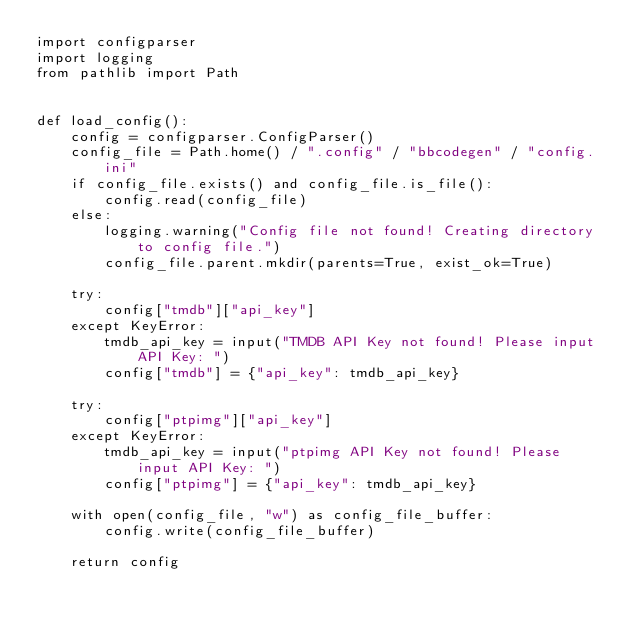Convert code to text. <code><loc_0><loc_0><loc_500><loc_500><_Python_>import configparser
import logging
from pathlib import Path


def load_config():
    config = configparser.ConfigParser()
    config_file = Path.home() / ".config" / "bbcodegen" / "config.ini"
    if config_file.exists() and config_file.is_file():
        config.read(config_file)
    else:
        logging.warning("Config file not found! Creating directory to config file.")
        config_file.parent.mkdir(parents=True, exist_ok=True)

    try:
        config["tmdb"]["api_key"]
    except KeyError:
        tmdb_api_key = input("TMDB API Key not found! Please input API Key: ")
        config["tmdb"] = {"api_key": tmdb_api_key}

    try:
        config["ptpimg"]["api_key"]
    except KeyError:
        tmdb_api_key = input("ptpimg API Key not found! Please input API Key: ")
        config["ptpimg"] = {"api_key": tmdb_api_key}

    with open(config_file, "w") as config_file_buffer:
        config.write(config_file_buffer)

    return config
</code> 